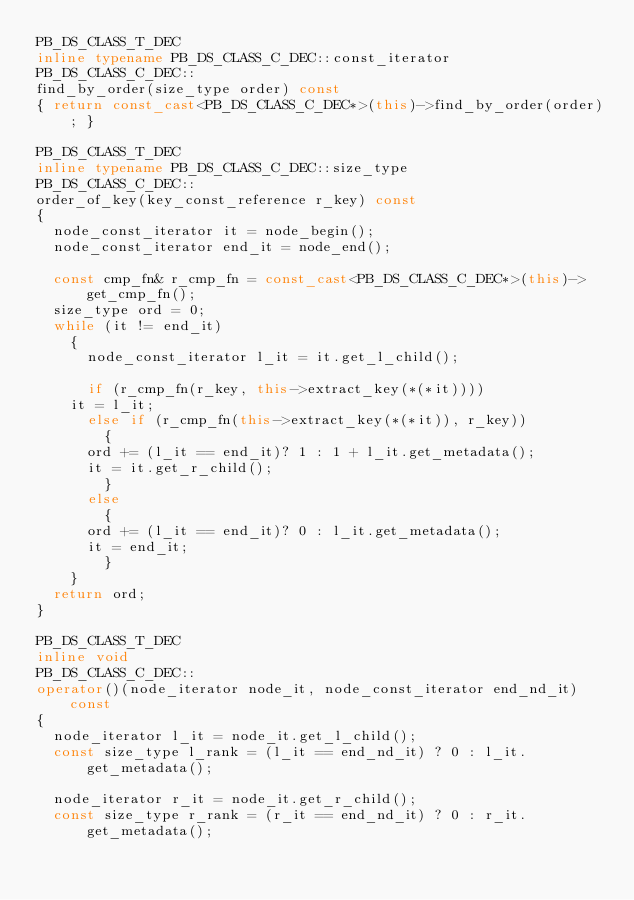Convert code to text. <code><loc_0><loc_0><loc_500><loc_500><_C++_>PB_DS_CLASS_T_DEC
inline typename PB_DS_CLASS_C_DEC::const_iterator
PB_DS_CLASS_C_DEC::
find_by_order(size_type order) const
{ return const_cast<PB_DS_CLASS_C_DEC*>(this)->find_by_order(order); }

PB_DS_CLASS_T_DEC
inline typename PB_DS_CLASS_C_DEC::size_type
PB_DS_CLASS_C_DEC::
order_of_key(key_const_reference r_key) const
{
  node_const_iterator it = node_begin();
  node_const_iterator end_it = node_end();

  const cmp_fn& r_cmp_fn = const_cast<PB_DS_CLASS_C_DEC*>(this)->get_cmp_fn();
  size_type ord = 0;
  while (it != end_it)
    {
      node_const_iterator l_it = it.get_l_child();

      if (r_cmp_fn(r_key, this->extract_key(*(*it))))
	it = l_it;
      else if (r_cmp_fn(this->extract_key(*(*it)), r_key))
        {
	  ord += (l_it == end_it)? 1 : 1 + l_it.get_metadata();
	  it = it.get_r_child();
        }
      else
        {
	  ord += (l_it == end_it)? 0 : l_it.get_metadata();
	  it = end_it;
        }
    }
  return ord;
}

PB_DS_CLASS_T_DEC
inline void
PB_DS_CLASS_C_DEC::
operator()(node_iterator node_it, node_const_iterator end_nd_it) const
{
  node_iterator l_it = node_it.get_l_child();
  const size_type l_rank = (l_it == end_nd_it) ? 0 : l_it.get_metadata();

  node_iterator r_it = node_it.get_r_child();
  const size_type r_rank = (r_it == end_nd_it) ? 0 : r_it.get_metadata();
</code> 